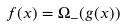Convert formula to latex. <formula><loc_0><loc_0><loc_500><loc_500>f ( x ) = \Omega _ { - } ( g ( x ) )</formula> 